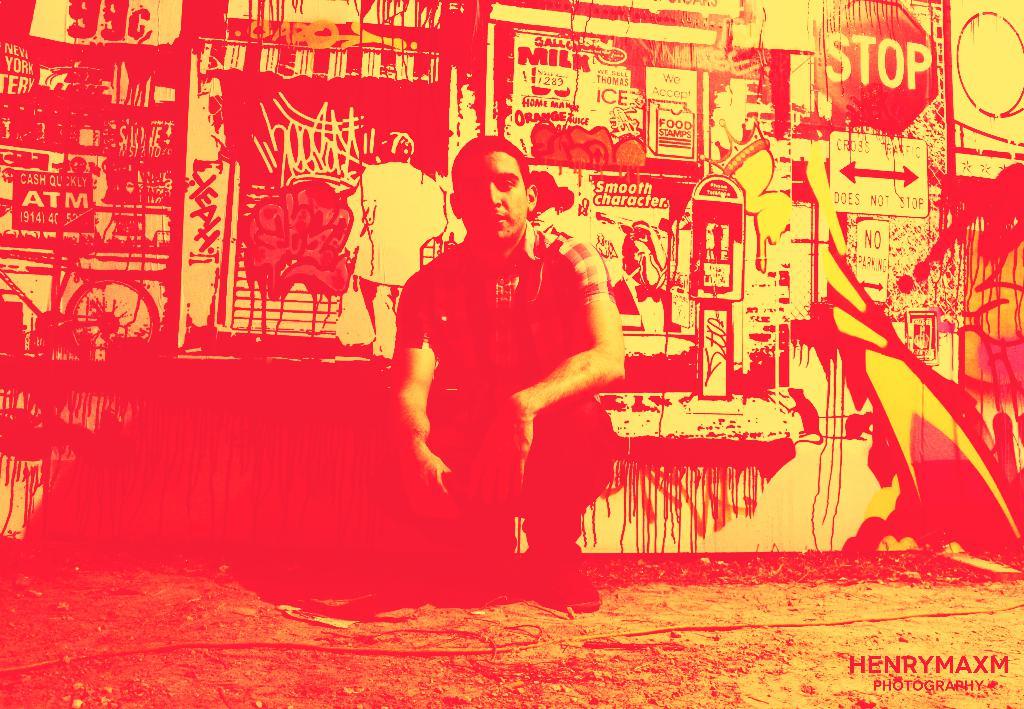Who photographed this?
Provide a short and direct response. Henry maxm. What is the sign instructing you to do?
Provide a short and direct response. Stop. 